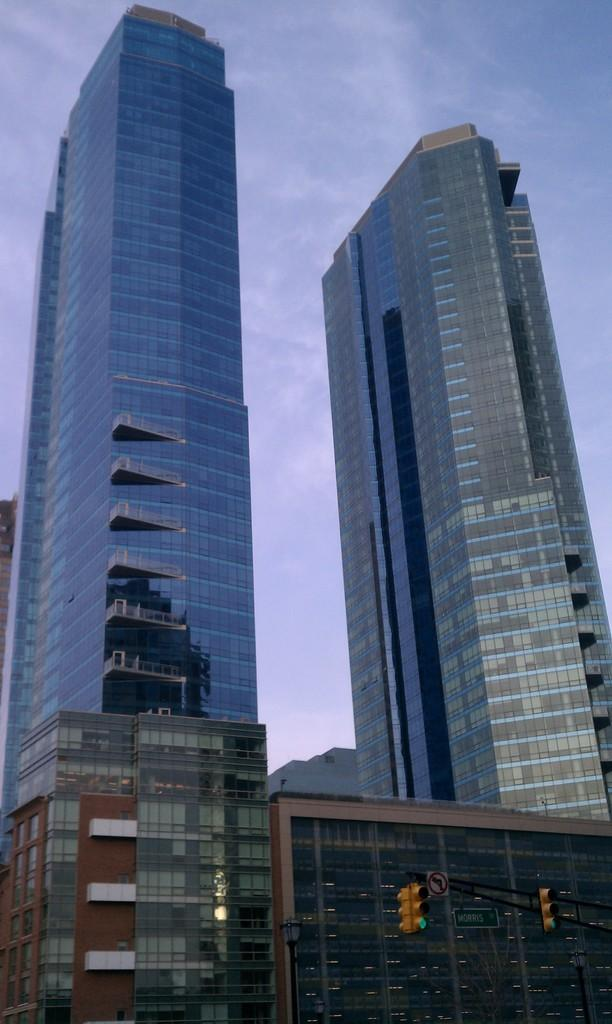What type of structures can be seen in the image? There are buildings in the image. What can be found at the bottom of the image? There are traffic lights and boards at the bottom of the image. What is visible in the sky at the top of the image? Clouds are present in the sky at the top of the image. What type of floor can be seen in the image? There is no floor visible in the image, as it appears to be an aerial view of the buildings and surrounding area. 